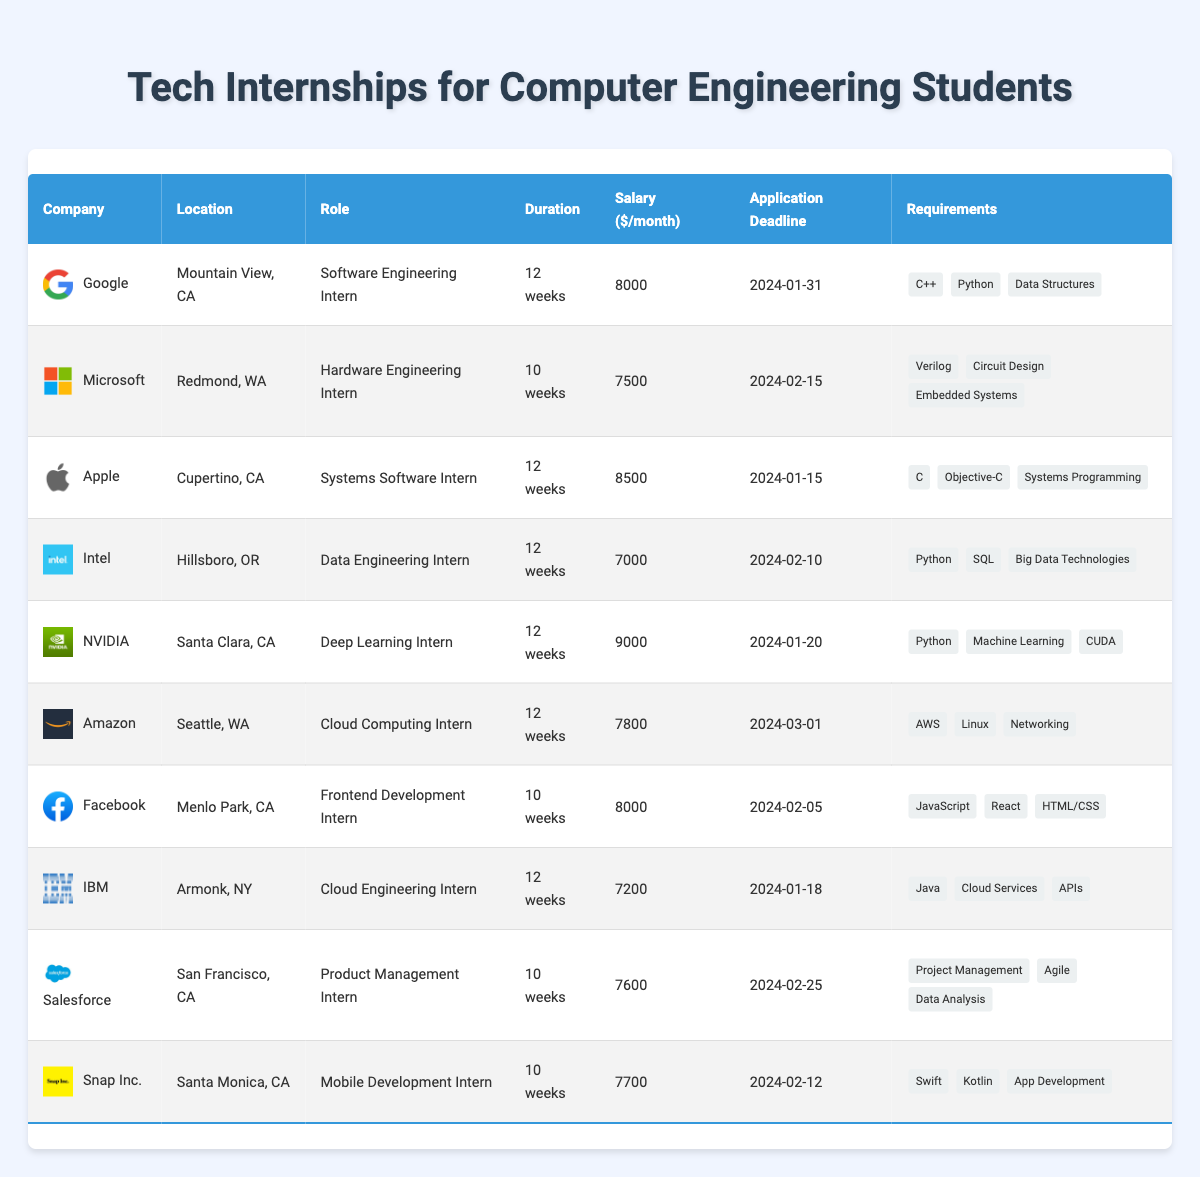What is the application deadline for the internship at Apple? The application deadline for the internship at Apple is listed in the table under the "Application Deadline" column corresponding to the row where Apple is mentioned. It states 2024-01-15.
Answer: 2024-01-15 Which company offers the highest monthly salary for their internship? Checking the "Salary" column reveals that NVIDIA offers the highest monthly salary of $9000 for their Deep Learning Intern position.
Answer: NVIDIA How many companies have internships located in California? By scanning the "Location" column for entries in California, we find Google, Apple, NVIDIA, Facebook, Salesforce, and Snap Inc., totaling 6 companies.
Answer: 6 Is there an internship at IBM that requires knowledge in Cloud Services? Looking in the "Requirements" column for IBM shows that "Cloud Services" is indeed listed as a required skill for the Cloud Engineering Intern role.
Answer: Yes What is the average salary of the internships listed in Washington state? The internships in Washington state are offered by Microsoft (7500) and Amazon (7800). The average is calculated as (7500 + 7800) / 2 = 7650.
Answer: 7650 How many internships have a duration of 10 weeks? By counting the "Duration" column, we see that both Microsoft, Facebook, Salesforce, and Snap Inc. have internships lasting 10 weeks, which totals to 4 internships.
Answer: 4 Which location has the largest salary range among the listed internships? To determine the range, we compare salaries in California (8000, 8500, 9000), New York (7200), and Washington (7500, 7800). The largest range occurs in California: 9000 - 8000 = 1000, and the smallest range occurs in New York: 7200 only has one value. The largest range is in California with 1000.
Answer: California Are there any internships that require Python as a skill? Reviewing the "Requirements" column, we find that Google, Intel, and NVIDIA all list Python as a required skill.
Answer: Yes What is the sum of the salaries for the internships in the tech industry? To find the sum, we add all the salaries: 8000 + 7500 + 8500 + 7000 + 9000 + 7800 + 8000 + 7200 + 7600 + 7700 = 76400.
Answer: 76400 Which company has the earliest application deadline? Scanning the "Application Deadline" column and comparing all dates shows that Apple has the earliest deadline listed as 2024-01-15.
Answer: Apple 